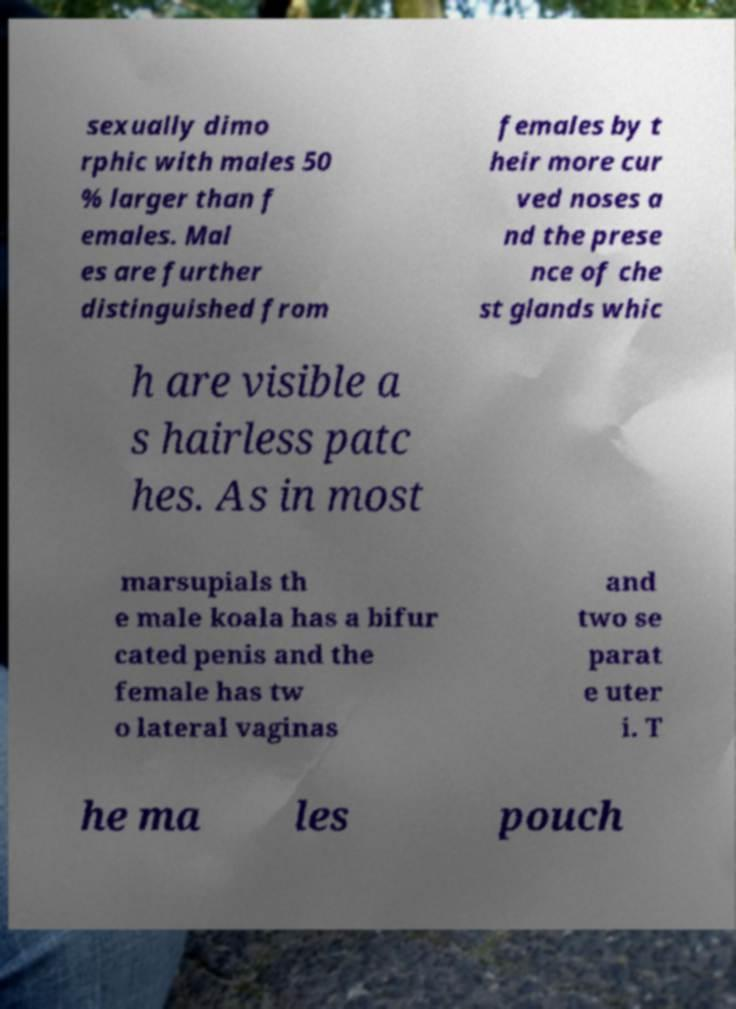Please read and relay the text visible in this image. What does it say? sexually dimo rphic with males 50 % larger than f emales. Mal es are further distinguished from females by t heir more cur ved noses a nd the prese nce of che st glands whic h are visible a s hairless patc hes. As in most marsupials th e male koala has a bifur cated penis and the female has tw o lateral vaginas and two se parat e uter i. T he ma les pouch 